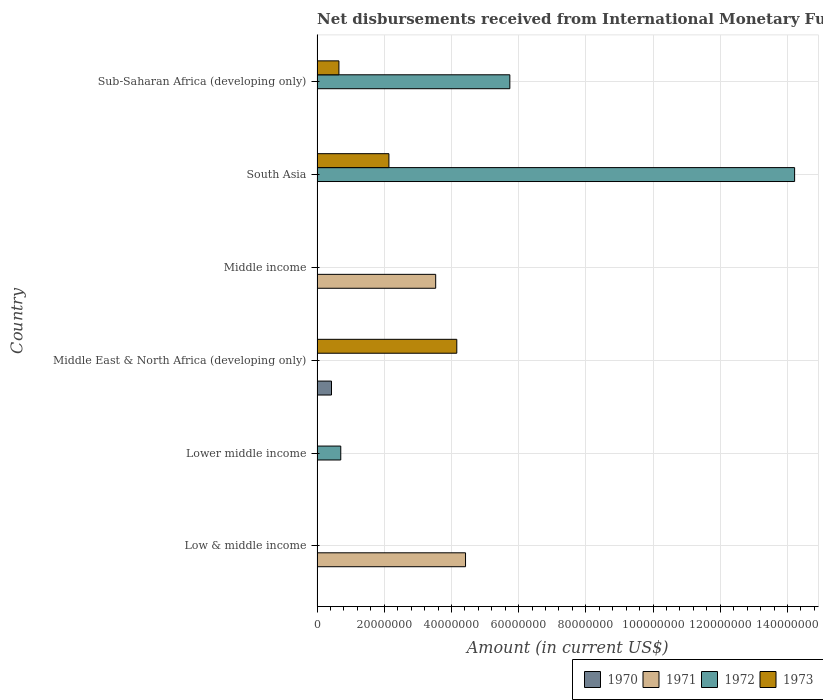Are the number of bars on each tick of the Y-axis equal?
Your answer should be compact. No. How many bars are there on the 4th tick from the top?
Make the answer very short. 2. In how many cases, is the number of bars for a given country not equal to the number of legend labels?
Your response must be concise. 6. Across all countries, what is the maximum amount of disbursements received from International Monetary Fund in 1972?
Offer a terse response. 1.42e+08. Across all countries, what is the minimum amount of disbursements received from International Monetary Fund in 1972?
Your answer should be compact. 0. In which country was the amount of disbursements received from International Monetary Fund in 1970 maximum?
Your response must be concise. Middle East & North Africa (developing only). What is the total amount of disbursements received from International Monetary Fund in 1972 in the graph?
Your answer should be very brief. 2.07e+08. What is the difference between the amount of disbursements received from International Monetary Fund in 1972 in South Asia and that in Sub-Saharan Africa (developing only)?
Your response must be concise. 8.48e+07. What is the difference between the amount of disbursements received from International Monetary Fund in 1970 in South Asia and the amount of disbursements received from International Monetary Fund in 1971 in Low & middle income?
Make the answer very short. -4.42e+07. What is the average amount of disbursements received from International Monetary Fund in 1971 per country?
Your answer should be compact. 1.32e+07. What is the difference between the amount of disbursements received from International Monetary Fund in 1973 and amount of disbursements received from International Monetary Fund in 1972 in South Asia?
Give a very brief answer. -1.21e+08. In how many countries, is the amount of disbursements received from International Monetary Fund in 1972 greater than 132000000 US$?
Ensure brevity in your answer.  1. Is the amount of disbursements received from International Monetary Fund in 1972 in Lower middle income less than that in South Asia?
Ensure brevity in your answer.  Yes. What is the difference between the highest and the lowest amount of disbursements received from International Monetary Fund in 1972?
Provide a succinct answer. 1.42e+08. In how many countries, is the amount of disbursements received from International Monetary Fund in 1971 greater than the average amount of disbursements received from International Monetary Fund in 1971 taken over all countries?
Your answer should be very brief. 2. Is it the case that in every country, the sum of the amount of disbursements received from International Monetary Fund in 1970 and amount of disbursements received from International Monetary Fund in 1971 is greater than the sum of amount of disbursements received from International Monetary Fund in 1973 and amount of disbursements received from International Monetary Fund in 1972?
Make the answer very short. No. Are all the bars in the graph horizontal?
Offer a very short reply. Yes. Are the values on the major ticks of X-axis written in scientific E-notation?
Provide a succinct answer. No. Does the graph contain any zero values?
Offer a terse response. Yes. How many legend labels are there?
Provide a short and direct response. 4. What is the title of the graph?
Offer a terse response. Net disbursements received from International Monetary Fund (non-concessional). Does "2010" appear as one of the legend labels in the graph?
Your answer should be very brief. No. What is the label or title of the Y-axis?
Give a very brief answer. Country. What is the Amount (in current US$) in 1971 in Low & middle income?
Your answer should be compact. 4.42e+07. What is the Amount (in current US$) of 1972 in Low & middle income?
Keep it short and to the point. 0. What is the Amount (in current US$) in 1972 in Lower middle income?
Provide a succinct answer. 7.06e+06. What is the Amount (in current US$) in 1970 in Middle East & North Africa (developing only)?
Your answer should be very brief. 4.30e+06. What is the Amount (in current US$) of 1973 in Middle East & North Africa (developing only)?
Offer a terse response. 4.16e+07. What is the Amount (in current US$) of 1970 in Middle income?
Your answer should be very brief. 0. What is the Amount (in current US$) of 1971 in Middle income?
Provide a short and direct response. 3.53e+07. What is the Amount (in current US$) of 1973 in Middle income?
Make the answer very short. 0. What is the Amount (in current US$) of 1970 in South Asia?
Offer a terse response. 0. What is the Amount (in current US$) of 1972 in South Asia?
Your answer should be compact. 1.42e+08. What is the Amount (in current US$) in 1973 in South Asia?
Ensure brevity in your answer.  2.14e+07. What is the Amount (in current US$) in 1971 in Sub-Saharan Africa (developing only)?
Provide a short and direct response. 0. What is the Amount (in current US$) of 1972 in Sub-Saharan Africa (developing only)?
Provide a short and direct response. 5.74e+07. What is the Amount (in current US$) in 1973 in Sub-Saharan Africa (developing only)?
Provide a succinct answer. 6.51e+06. Across all countries, what is the maximum Amount (in current US$) in 1970?
Ensure brevity in your answer.  4.30e+06. Across all countries, what is the maximum Amount (in current US$) in 1971?
Your response must be concise. 4.42e+07. Across all countries, what is the maximum Amount (in current US$) in 1972?
Make the answer very short. 1.42e+08. Across all countries, what is the maximum Amount (in current US$) of 1973?
Keep it short and to the point. 4.16e+07. Across all countries, what is the minimum Amount (in current US$) in 1971?
Your answer should be compact. 0. Across all countries, what is the minimum Amount (in current US$) in 1972?
Offer a very short reply. 0. Across all countries, what is the minimum Amount (in current US$) in 1973?
Keep it short and to the point. 0. What is the total Amount (in current US$) in 1970 in the graph?
Make the answer very short. 4.30e+06. What is the total Amount (in current US$) in 1971 in the graph?
Your response must be concise. 7.95e+07. What is the total Amount (in current US$) of 1972 in the graph?
Make the answer very short. 2.07e+08. What is the total Amount (in current US$) of 1973 in the graph?
Keep it short and to the point. 6.95e+07. What is the difference between the Amount (in current US$) in 1971 in Low & middle income and that in Middle income?
Offer a terse response. 8.88e+06. What is the difference between the Amount (in current US$) of 1972 in Lower middle income and that in South Asia?
Keep it short and to the point. -1.35e+08. What is the difference between the Amount (in current US$) of 1972 in Lower middle income and that in Sub-Saharan Africa (developing only)?
Make the answer very short. -5.03e+07. What is the difference between the Amount (in current US$) in 1973 in Middle East & North Africa (developing only) and that in South Asia?
Your answer should be compact. 2.02e+07. What is the difference between the Amount (in current US$) in 1973 in Middle East & North Africa (developing only) and that in Sub-Saharan Africa (developing only)?
Your answer should be very brief. 3.51e+07. What is the difference between the Amount (in current US$) of 1972 in South Asia and that in Sub-Saharan Africa (developing only)?
Your answer should be very brief. 8.48e+07. What is the difference between the Amount (in current US$) in 1973 in South Asia and that in Sub-Saharan Africa (developing only)?
Your response must be concise. 1.49e+07. What is the difference between the Amount (in current US$) of 1971 in Low & middle income and the Amount (in current US$) of 1972 in Lower middle income?
Your answer should be compact. 3.71e+07. What is the difference between the Amount (in current US$) in 1971 in Low & middle income and the Amount (in current US$) in 1973 in Middle East & North Africa (developing only)?
Keep it short and to the point. 2.60e+06. What is the difference between the Amount (in current US$) in 1971 in Low & middle income and the Amount (in current US$) in 1972 in South Asia?
Your response must be concise. -9.79e+07. What is the difference between the Amount (in current US$) of 1971 in Low & middle income and the Amount (in current US$) of 1973 in South Asia?
Ensure brevity in your answer.  2.28e+07. What is the difference between the Amount (in current US$) in 1971 in Low & middle income and the Amount (in current US$) in 1972 in Sub-Saharan Africa (developing only)?
Offer a very short reply. -1.32e+07. What is the difference between the Amount (in current US$) in 1971 in Low & middle income and the Amount (in current US$) in 1973 in Sub-Saharan Africa (developing only)?
Provide a short and direct response. 3.77e+07. What is the difference between the Amount (in current US$) of 1972 in Lower middle income and the Amount (in current US$) of 1973 in Middle East & North Africa (developing only)?
Offer a very short reply. -3.45e+07. What is the difference between the Amount (in current US$) in 1972 in Lower middle income and the Amount (in current US$) in 1973 in South Asia?
Your answer should be compact. -1.43e+07. What is the difference between the Amount (in current US$) in 1972 in Lower middle income and the Amount (in current US$) in 1973 in Sub-Saharan Africa (developing only)?
Provide a succinct answer. 5.46e+05. What is the difference between the Amount (in current US$) of 1970 in Middle East & North Africa (developing only) and the Amount (in current US$) of 1971 in Middle income?
Your answer should be compact. -3.10e+07. What is the difference between the Amount (in current US$) of 1970 in Middle East & North Africa (developing only) and the Amount (in current US$) of 1972 in South Asia?
Provide a succinct answer. -1.38e+08. What is the difference between the Amount (in current US$) in 1970 in Middle East & North Africa (developing only) and the Amount (in current US$) in 1973 in South Asia?
Ensure brevity in your answer.  -1.71e+07. What is the difference between the Amount (in current US$) in 1970 in Middle East & North Africa (developing only) and the Amount (in current US$) in 1972 in Sub-Saharan Africa (developing only)?
Give a very brief answer. -5.31e+07. What is the difference between the Amount (in current US$) in 1970 in Middle East & North Africa (developing only) and the Amount (in current US$) in 1973 in Sub-Saharan Africa (developing only)?
Ensure brevity in your answer.  -2.21e+06. What is the difference between the Amount (in current US$) in 1971 in Middle income and the Amount (in current US$) in 1972 in South Asia?
Offer a very short reply. -1.07e+08. What is the difference between the Amount (in current US$) of 1971 in Middle income and the Amount (in current US$) of 1973 in South Asia?
Offer a very short reply. 1.39e+07. What is the difference between the Amount (in current US$) of 1971 in Middle income and the Amount (in current US$) of 1972 in Sub-Saharan Africa (developing only)?
Make the answer very short. -2.21e+07. What is the difference between the Amount (in current US$) in 1971 in Middle income and the Amount (in current US$) in 1973 in Sub-Saharan Africa (developing only)?
Ensure brevity in your answer.  2.88e+07. What is the difference between the Amount (in current US$) in 1972 in South Asia and the Amount (in current US$) in 1973 in Sub-Saharan Africa (developing only)?
Offer a terse response. 1.36e+08. What is the average Amount (in current US$) of 1970 per country?
Give a very brief answer. 7.17e+05. What is the average Amount (in current US$) in 1971 per country?
Provide a succinct answer. 1.32e+07. What is the average Amount (in current US$) of 1972 per country?
Provide a succinct answer. 3.44e+07. What is the average Amount (in current US$) in 1973 per country?
Give a very brief answer. 1.16e+07. What is the difference between the Amount (in current US$) in 1970 and Amount (in current US$) in 1973 in Middle East & North Africa (developing only)?
Offer a very short reply. -3.73e+07. What is the difference between the Amount (in current US$) in 1972 and Amount (in current US$) in 1973 in South Asia?
Make the answer very short. 1.21e+08. What is the difference between the Amount (in current US$) in 1972 and Amount (in current US$) in 1973 in Sub-Saharan Africa (developing only)?
Make the answer very short. 5.09e+07. What is the ratio of the Amount (in current US$) of 1971 in Low & middle income to that in Middle income?
Give a very brief answer. 1.25. What is the ratio of the Amount (in current US$) in 1972 in Lower middle income to that in South Asia?
Give a very brief answer. 0.05. What is the ratio of the Amount (in current US$) of 1972 in Lower middle income to that in Sub-Saharan Africa (developing only)?
Offer a terse response. 0.12. What is the ratio of the Amount (in current US$) of 1973 in Middle East & North Africa (developing only) to that in South Asia?
Your answer should be compact. 1.94. What is the ratio of the Amount (in current US$) of 1973 in Middle East & North Africa (developing only) to that in Sub-Saharan Africa (developing only)?
Offer a terse response. 6.39. What is the ratio of the Amount (in current US$) of 1972 in South Asia to that in Sub-Saharan Africa (developing only)?
Give a very brief answer. 2.48. What is the ratio of the Amount (in current US$) of 1973 in South Asia to that in Sub-Saharan Africa (developing only)?
Your answer should be compact. 3.29. What is the difference between the highest and the second highest Amount (in current US$) in 1972?
Give a very brief answer. 8.48e+07. What is the difference between the highest and the second highest Amount (in current US$) in 1973?
Your response must be concise. 2.02e+07. What is the difference between the highest and the lowest Amount (in current US$) of 1970?
Your answer should be compact. 4.30e+06. What is the difference between the highest and the lowest Amount (in current US$) of 1971?
Offer a very short reply. 4.42e+07. What is the difference between the highest and the lowest Amount (in current US$) in 1972?
Give a very brief answer. 1.42e+08. What is the difference between the highest and the lowest Amount (in current US$) of 1973?
Ensure brevity in your answer.  4.16e+07. 